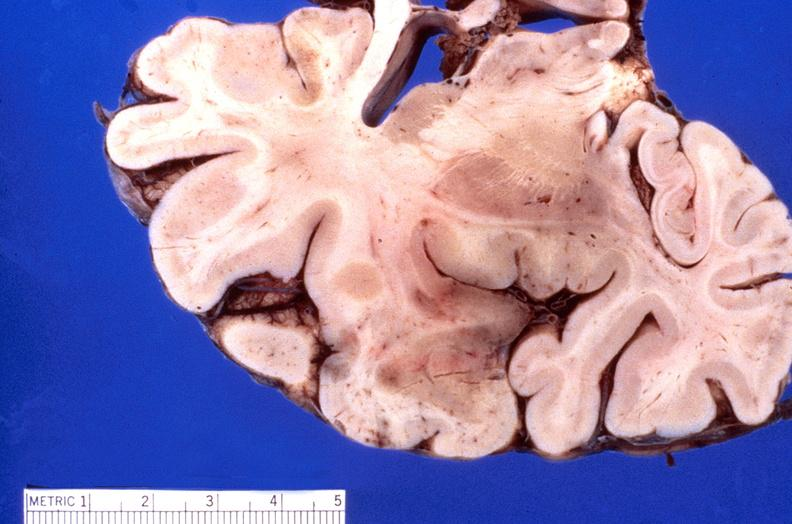does splenomegaly with cirrhosis show brain, herpes encephalitis?
Answer the question using a single word or phrase. No 